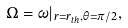Convert formula to latex. <formula><loc_0><loc_0><loc_500><loc_500>\Omega = \omega | _ { r = r _ { t h } , \theta = \pi / 2 } ,</formula> 